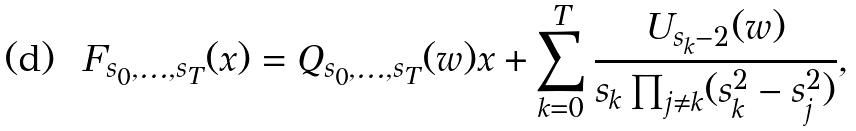<formula> <loc_0><loc_0><loc_500><loc_500>F _ { s _ { 0 } , \dots , s _ { T } } ( x ) = Q _ { s _ { 0 } , \dots , s _ { T } } ( w ) x + \sum _ { k = 0 } ^ { T } \frac { U _ { s _ { k } - 2 } ( w ) } { s _ { k } \prod _ { j \neq k } ( s _ { k } ^ { 2 } - s _ { j } ^ { 2 } ) } ,</formula> 